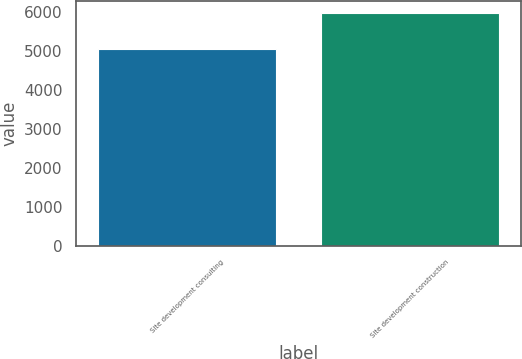Convert chart. <chart><loc_0><loc_0><loc_500><loc_500><bar_chart><fcel>Site development consulting<fcel>Site development construction<nl><fcel>5054<fcel>5982<nl></chart> 